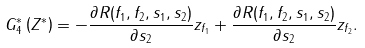<formula> <loc_0><loc_0><loc_500><loc_500>G ^ { * } _ { 4 } \left ( Z ^ { * } \right ) = - \frac { \partial R ( f _ { 1 } , f _ { 2 } , s _ { 1 } , s _ { 2 } ) } { \partial s _ { 2 } } z _ { f _ { 1 } } + \frac { \partial R ( f _ { 1 } , f _ { 2 } , s _ { 1 } , s _ { 2 } ) } { \partial s _ { 2 } } z _ { f _ { 2 } } .</formula> 